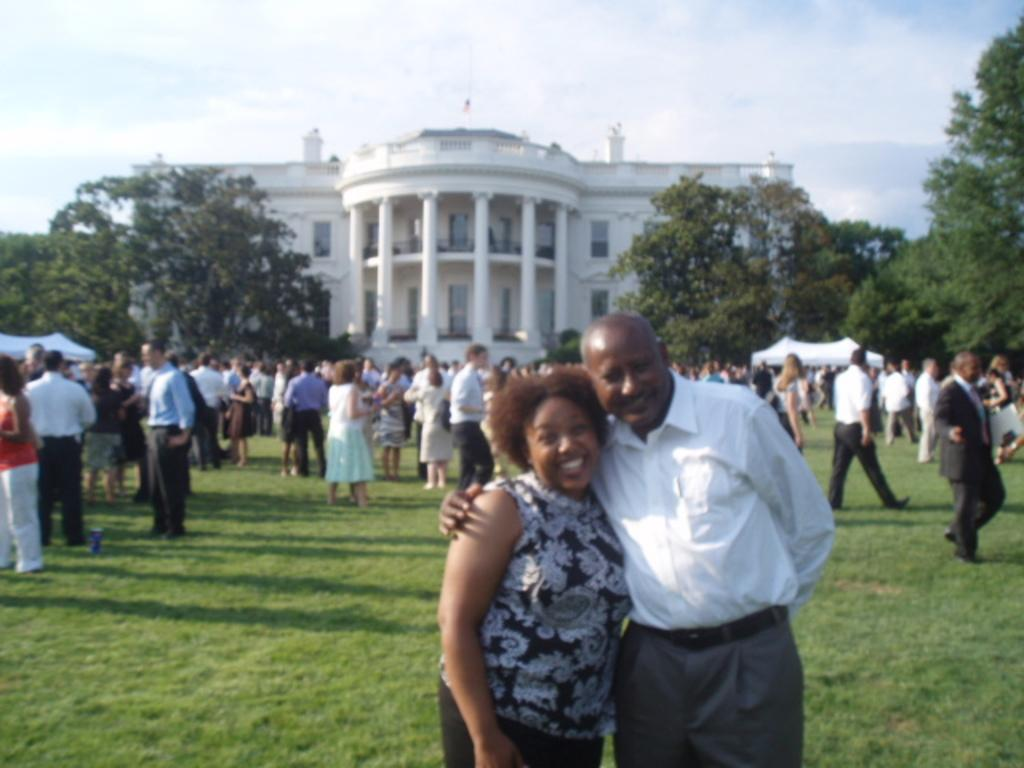What is the main subject of the image? The main subject of the image is a crowd standing on the ground. What can be seen in the background of the image? The sky with clouds, trees, tents, and a building are visible in the background of the image. How many mice are sitting on the cup in the image? There is no cup or mice present in the image. 